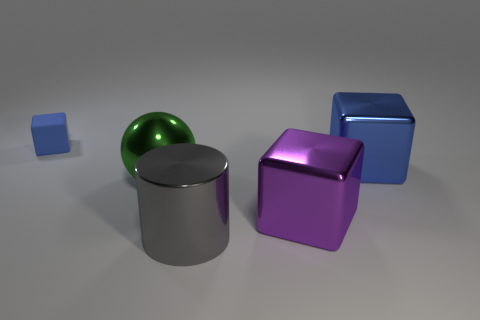Is there a big purple shiny block right of the big metal block behind the green object on the left side of the big blue metallic thing?
Your response must be concise. No. Is there anything else that has the same shape as the large purple object?
Offer a terse response. Yes. There is a metallic thing left of the large gray metallic cylinder; is its color the same as the small thing that is behind the large green object?
Make the answer very short. No. Are any tiny cylinders visible?
Offer a very short reply. No. What material is the large object that is the same color as the small rubber thing?
Your answer should be very brief. Metal. There is a gray metallic object in front of the large block in front of the green metal object that is behind the gray thing; what is its size?
Your answer should be very brief. Large. Does the gray shiny object have the same shape as the metal object behind the metallic ball?
Give a very brief answer. No. Are there any things of the same color as the large metallic cylinder?
Offer a very short reply. No. How many balls are either tiny matte objects or large purple objects?
Your answer should be compact. 0. Is there another tiny thing of the same shape as the blue shiny thing?
Your answer should be very brief. Yes. 